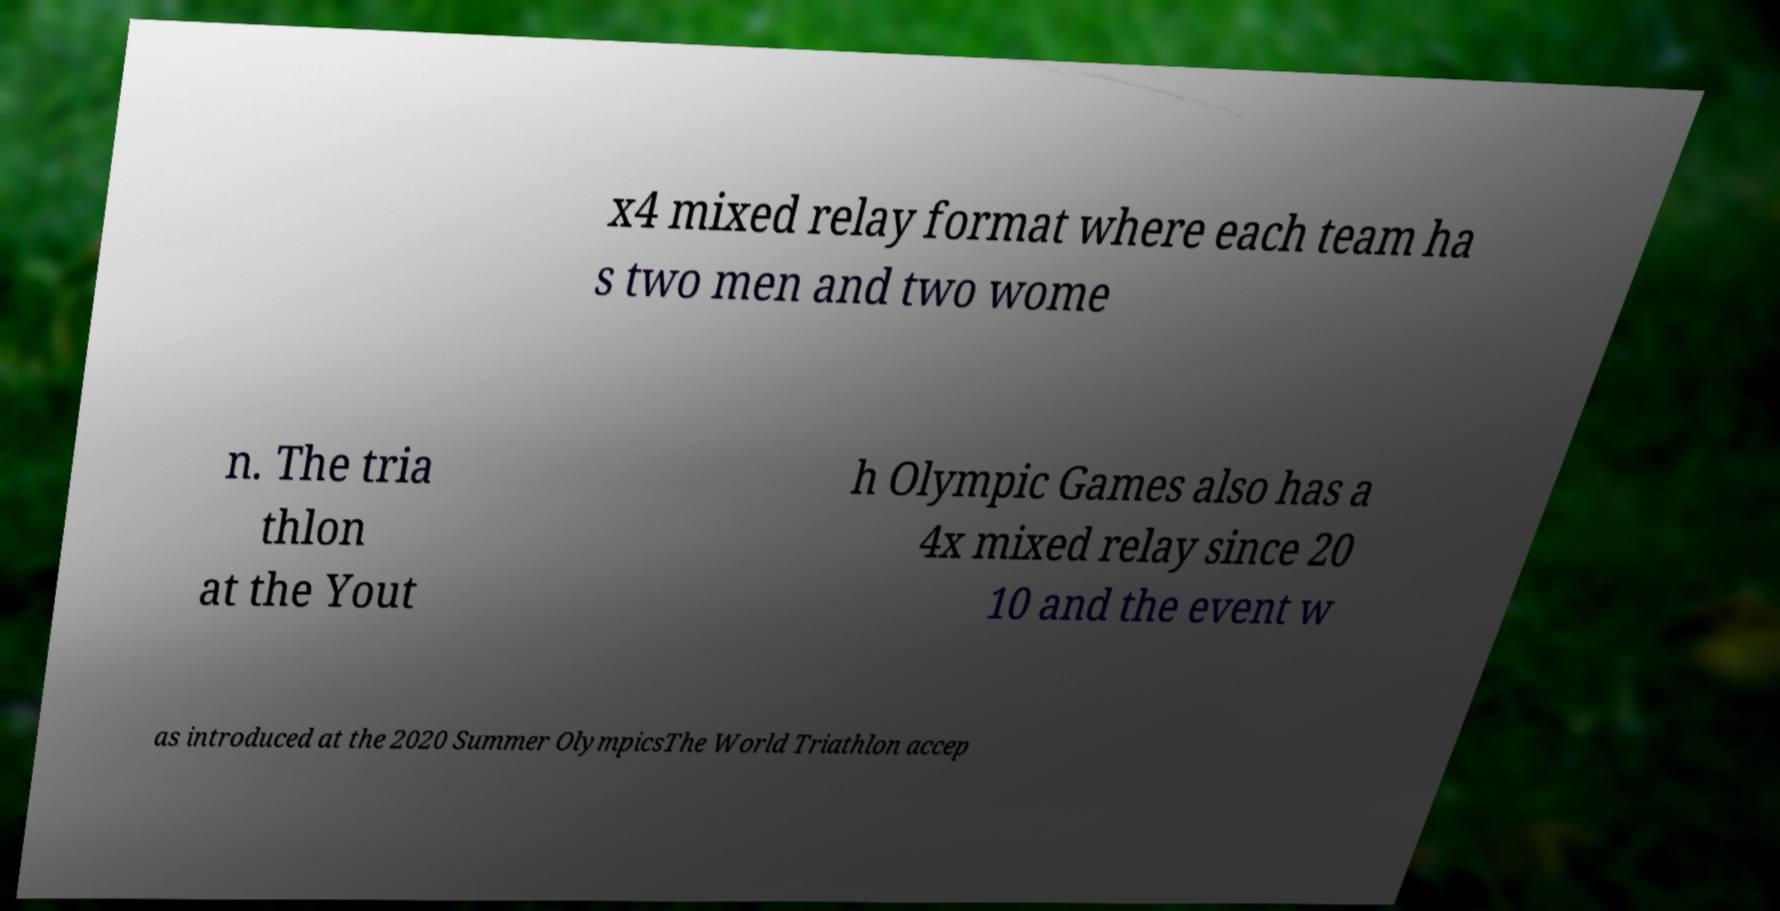Can you accurately transcribe the text from the provided image for me? x4 mixed relay format where each team ha s two men and two wome n. The tria thlon at the Yout h Olympic Games also has a 4x mixed relay since 20 10 and the event w as introduced at the 2020 Summer OlympicsThe World Triathlon accep 